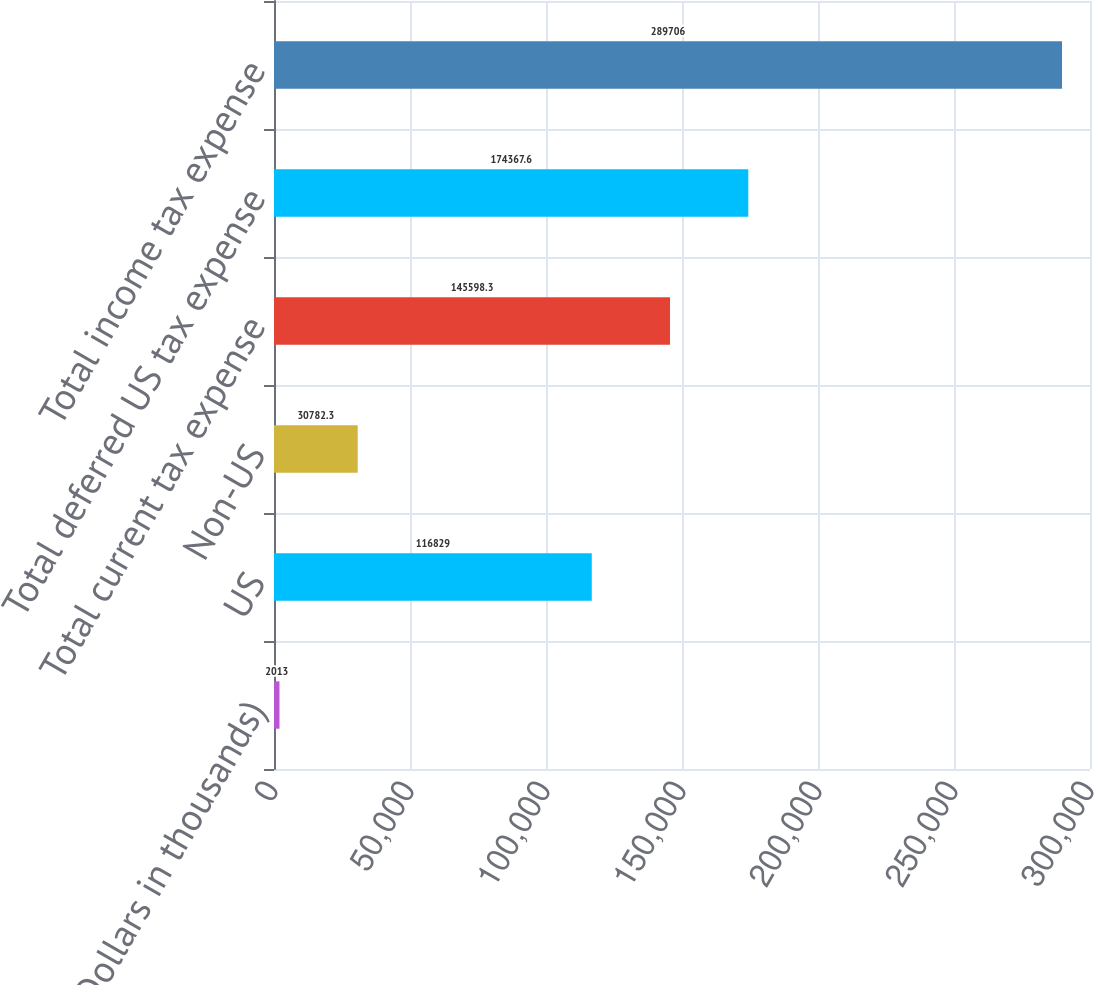Convert chart to OTSL. <chart><loc_0><loc_0><loc_500><loc_500><bar_chart><fcel>(Dollars in thousands)<fcel>US<fcel>Non-US<fcel>Total current tax expense<fcel>Total deferred US tax expense<fcel>Total income tax expense<nl><fcel>2013<fcel>116829<fcel>30782.3<fcel>145598<fcel>174368<fcel>289706<nl></chart> 